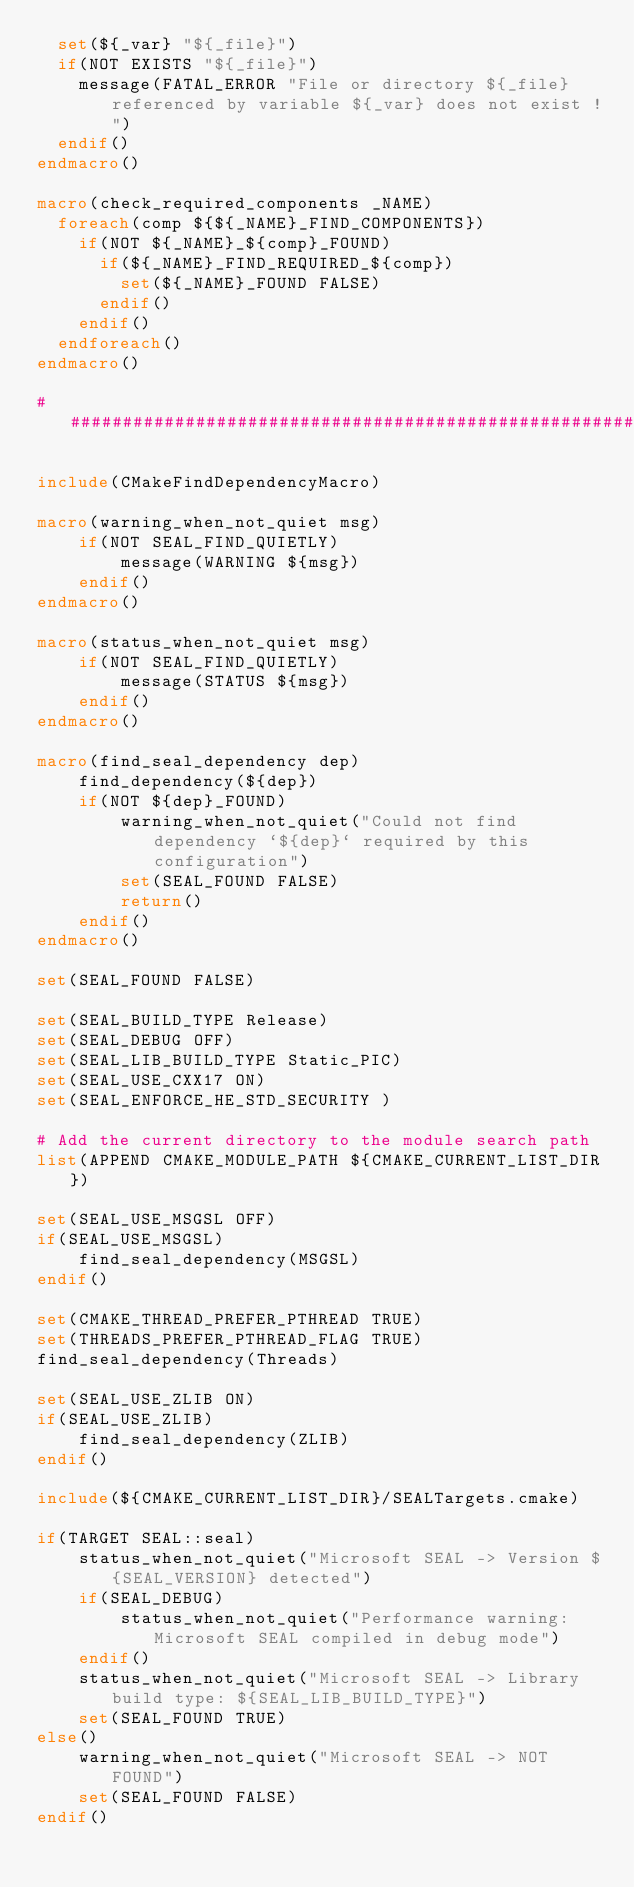Convert code to text. <code><loc_0><loc_0><loc_500><loc_500><_CMake_>  set(${_var} "${_file}")
  if(NOT EXISTS "${_file}")
    message(FATAL_ERROR "File or directory ${_file} referenced by variable ${_var} does not exist !")
  endif()
endmacro()

macro(check_required_components _NAME)
  foreach(comp ${${_NAME}_FIND_COMPONENTS})
    if(NOT ${_NAME}_${comp}_FOUND)
      if(${_NAME}_FIND_REQUIRED_${comp})
        set(${_NAME}_FOUND FALSE)
      endif()
    endif()
  endforeach()
endmacro()

####################################################################################

include(CMakeFindDependencyMacro)

macro(warning_when_not_quiet msg)
    if(NOT SEAL_FIND_QUIETLY)
        message(WARNING ${msg})
    endif()
endmacro()

macro(status_when_not_quiet msg)
    if(NOT SEAL_FIND_QUIETLY)
        message(STATUS ${msg})
    endif()
endmacro()

macro(find_seal_dependency dep)
    find_dependency(${dep})
    if(NOT ${dep}_FOUND)
        warning_when_not_quiet("Could not find dependency `${dep}` required by this configuration")
        set(SEAL_FOUND FALSE)
        return()
    endif()
endmacro()

set(SEAL_FOUND FALSE)

set(SEAL_BUILD_TYPE Release)
set(SEAL_DEBUG OFF)
set(SEAL_LIB_BUILD_TYPE Static_PIC)
set(SEAL_USE_CXX17 ON)
set(SEAL_ENFORCE_HE_STD_SECURITY )

# Add the current directory to the module search path
list(APPEND CMAKE_MODULE_PATH ${CMAKE_CURRENT_LIST_DIR})

set(SEAL_USE_MSGSL OFF)
if(SEAL_USE_MSGSL)
    find_seal_dependency(MSGSL)
endif()

set(CMAKE_THREAD_PREFER_PTHREAD TRUE)
set(THREADS_PREFER_PTHREAD_FLAG TRUE)
find_seal_dependency(Threads)

set(SEAL_USE_ZLIB ON)
if(SEAL_USE_ZLIB)
    find_seal_dependency(ZLIB)
endif()

include(${CMAKE_CURRENT_LIST_DIR}/SEALTargets.cmake)

if(TARGET SEAL::seal)
    status_when_not_quiet("Microsoft SEAL -> Version ${SEAL_VERSION} detected")
    if(SEAL_DEBUG)
        status_when_not_quiet("Performance warning: Microsoft SEAL compiled in debug mode")
    endif()
    status_when_not_quiet("Microsoft SEAL -> Library build type: ${SEAL_LIB_BUILD_TYPE}")
    set(SEAL_FOUND TRUE)
else()
    warning_when_not_quiet("Microsoft SEAL -> NOT FOUND")
    set(SEAL_FOUND FALSE)
endif()

</code> 